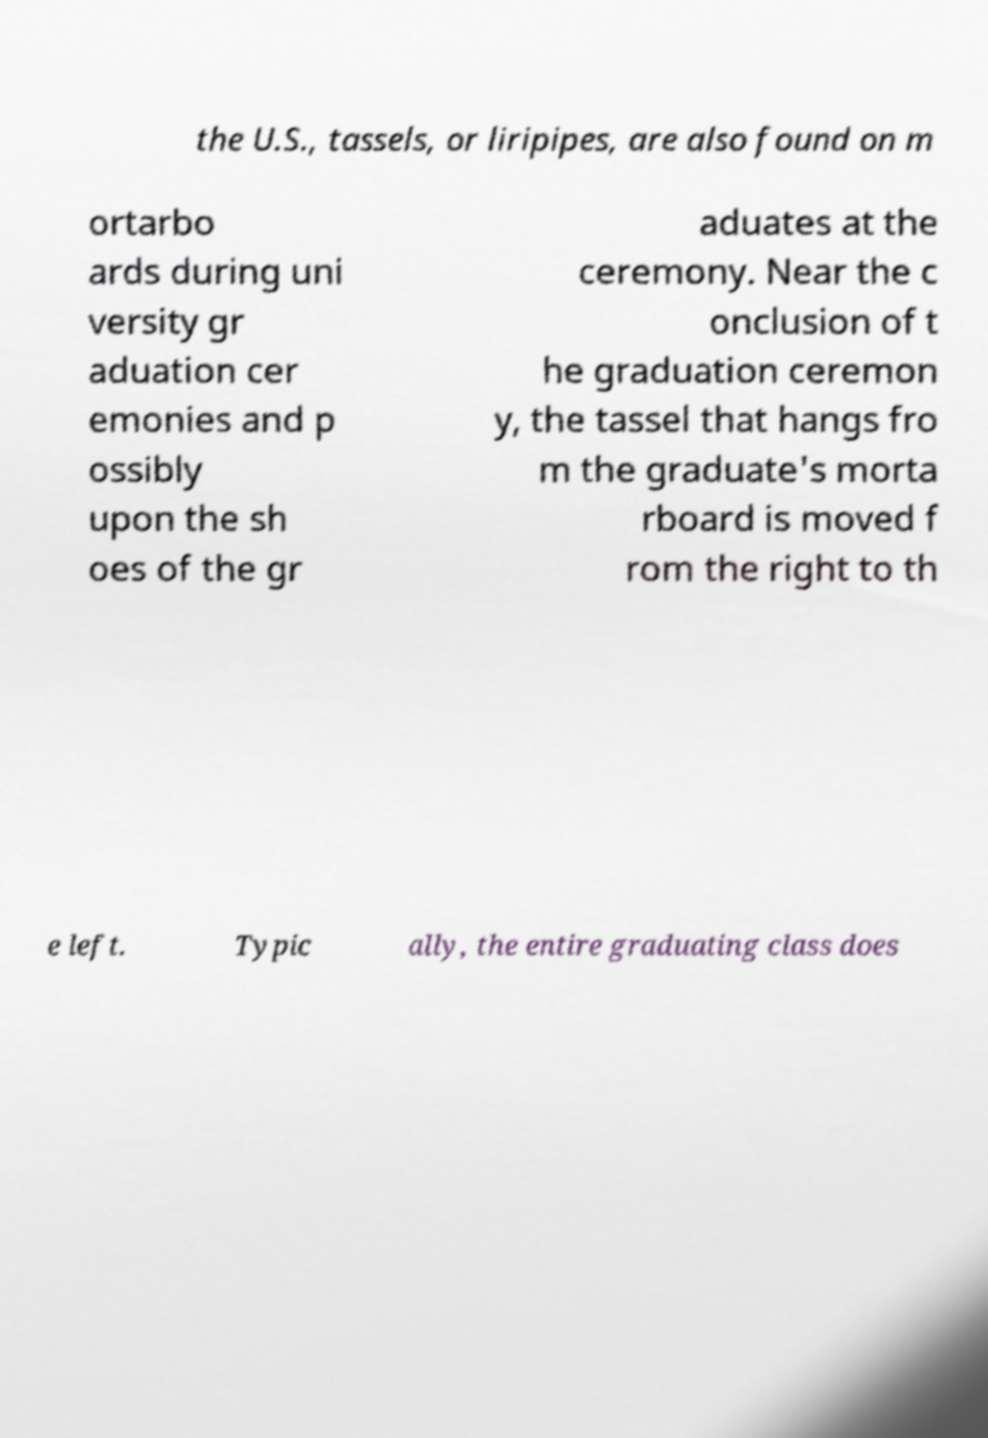For documentation purposes, I need the text within this image transcribed. Could you provide that? the U.S., tassels, or liripipes, are also found on m ortarbo ards during uni versity gr aduation cer emonies and p ossibly upon the sh oes of the gr aduates at the ceremony. Near the c onclusion of t he graduation ceremon y, the tassel that hangs fro m the graduate's morta rboard is moved f rom the right to th e left. Typic ally, the entire graduating class does 